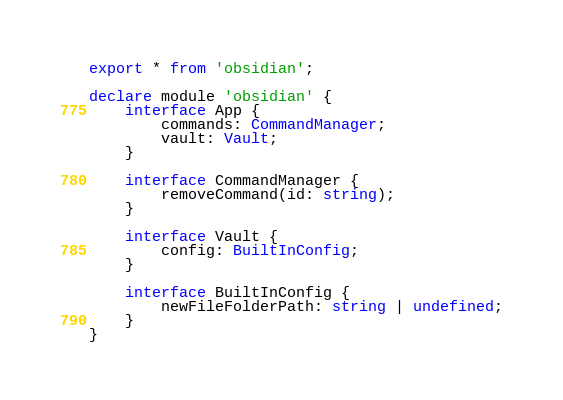Convert code to text. <code><loc_0><loc_0><loc_500><loc_500><_TypeScript_>export * from 'obsidian';

declare module 'obsidian' {
	interface App {
		commands: CommandManager;
		vault: Vault;
	}

	interface CommandManager {
		removeCommand(id: string);
	}

	interface Vault {
		config: BuiltInConfig;
	}

	interface BuiltInConfig {
		newFileFolderPath: string | undefined;
	}
}
</code> 